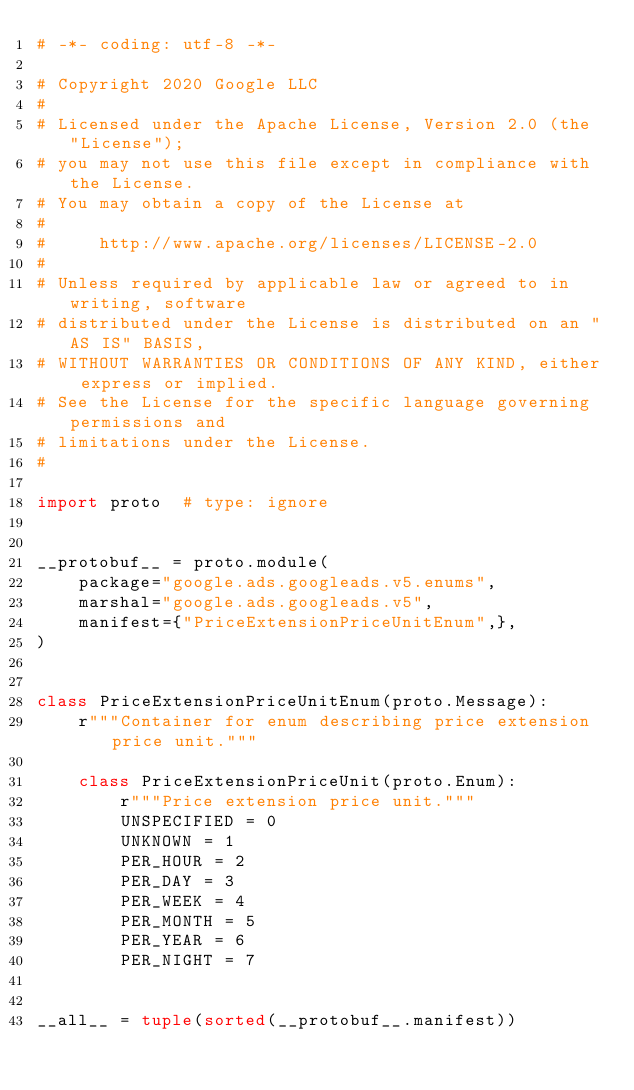Convert code to text. <code><loc_0><loc_0><loc_500><loc_500><_Python_># -*- coding: utf-8 -*-

# Copyright 2020 Google LLC
#
# Licensed under the Apache License, Version 2.0 (the "License");
# you may not use this file except in compliance with the License.
# You may obtain a copy of the License at
#
#     http://www.apache.org/licenses/LICENSE-2.0
#
# Unless required by applicable law or agreed to in writing, software
# distributed under the License is distributed on an "AS IS" BASIS,
# WITHOUT WARRANTIES OR CONDITIONS OF ANY KIND, either express or implied.
# See the License for the specific language governing permissions and
# limitations under the License.
#

import proto  # type: ignore


__protobuf__ = proto.module(
    package="google.ads.googleads.v5.enums",
    marshal="google.ads.googleads.v5",
    manifest={"PriceExtensionPriceUnitEnum",},
)


class PriceExtensionPriceUnitEnum(proto.Message):
    r"""Container for enum describing price extension price unit."""

    class PriceExtensionPriceUnit(proto.Enum):
        r"""Price extension price unit."""
        UNSPECIFIED = 0
        UNKNOWN = 1
        PER_HOUR = 2
        PER_DAY = 3
        PER_WEEK = 4
        PER_MONTH = 5
        PER_YEAR = 6
        PER_NIGHT = 7


__all__ = tuple(sorted(__protobuf__.manifest))
</code> 